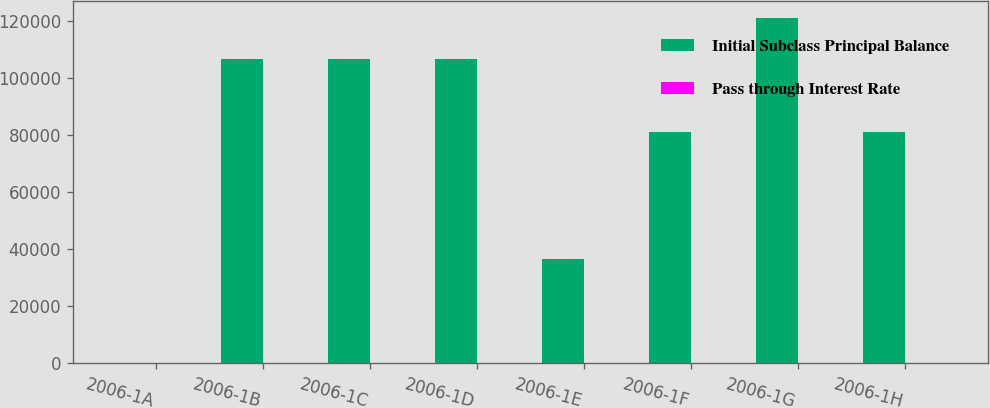<chart> <loc_0><loc_0><loc_500><loc_500><stacked_bar_chart><ecel><fcel>2006-1A<fcel>2006-1B<fcel>2006-1C<fcel>2006-1D<fcel>2006-1E<fcel>2006-1F<fcel>2006-1G<fcel>2006-1H<nl><fcel>Initial Subclass Principal Balance<fcel>7.39<fcel>106680<fcel>106680<fcel>106680<fcel>36540<fcel>81000<fcel>121000<fcel>81000<nl><fcel>Pass through Interest Rate<fcel>5.31<fcel>5.45<fcel>5.56<fcel>5.85<fcel>6.17<fcel>6.71<fcel>6.9<fcel>7.39<nl></chart> 